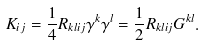Convert formula to latex. <formula><loc_0><loc_0><loc_500><loc_500>K _ { i j } = \frac { 1 } { 4 } R _ { k l i j } \gamma ^ { k } \gamma ^ { l } = \frac { 1 } { 2 } R _ { k l i j } G ^ { k l } .</formula> 